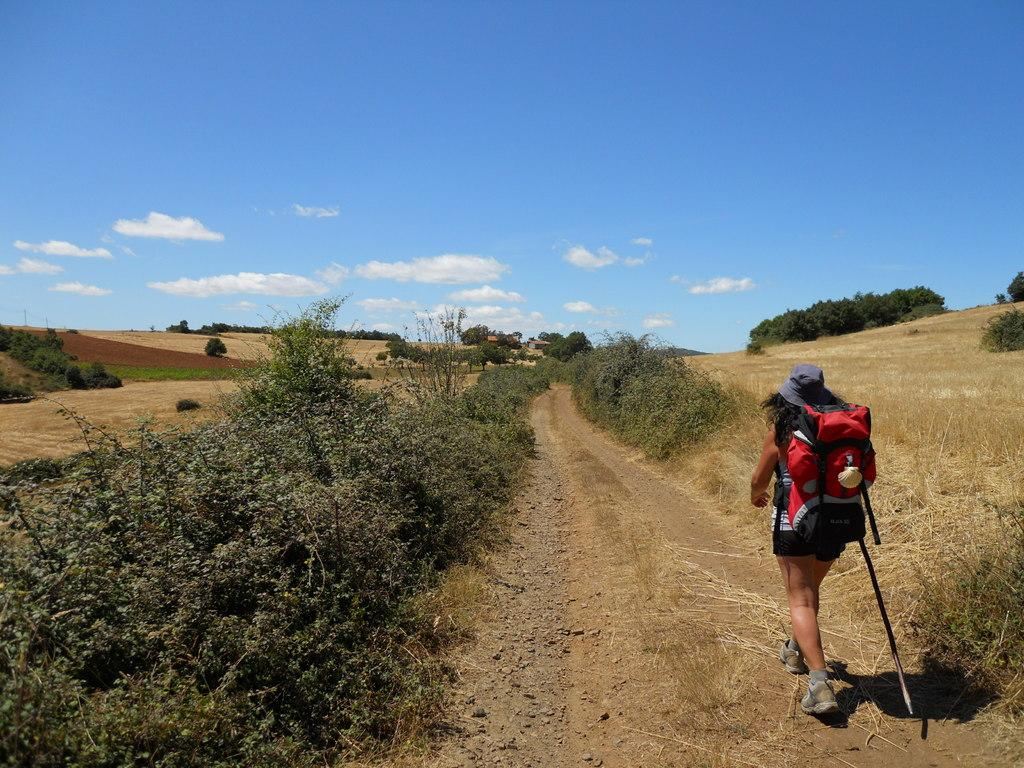What type of vegetation can be seen in the image? There are trees and grass in the image. What is the person in the image wearing? The person in the image is wearing a bag. What is the person in the image holding? The person in the image is holding a stick. What is the color of the sky in the image? The sky is blue and white in color. How many strings are attached to the ant in the image? There is no ant present in the image, and therefore no strings attached to it. What is the result of adding the number of trees and the number of grass blades in the image? It is impossible to determine the exact number of trees and grass blades in the image, so it is not possible to perform the addition. 